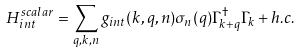<formula> <loc_0><loc_0><loc_500><loc_500>H _ { i n t } ^ { s c a l a r } = \sum _ { q , k , n } g _ { i n t } ( k , q , n ) \sigma _ { n } ( q ) \Gamma ^ { \dag } _ { k + q } \Gamma _ { k } + h . c .</formula> 